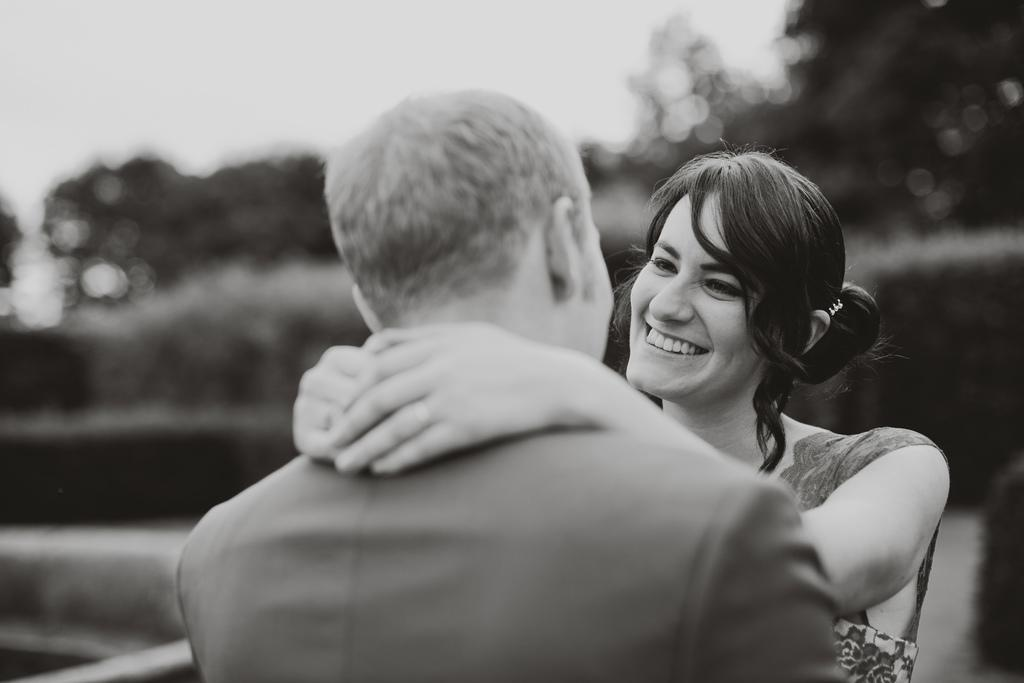How many people are present in the image? There is a man and a woman in the image. What is the color scheme of the image? The image is black and white. Can you describe the background of the image? The background of the image is blurred. What type of rose can be seen in the image? There is no rose present in the image. Can you describe the zebra in the image? There is no zebra present in the image. 